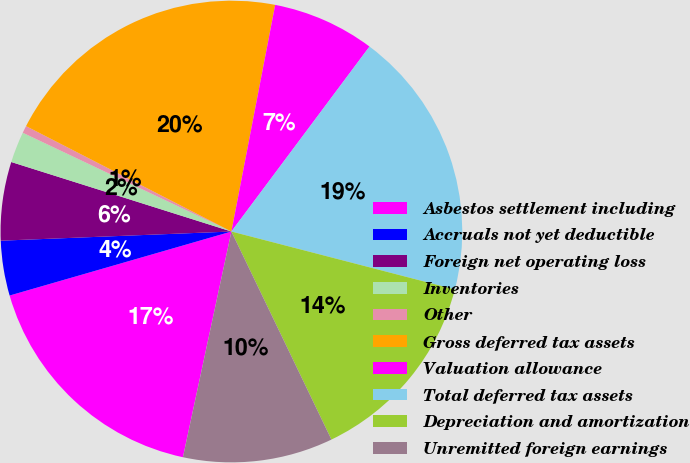Convert chart. <chart><loc_0><loc_0><loc_500><loc_500><pie_chart><fcel>Asbestos settlement including<fcel>Accruals not yet deductible<fcel>Foreign net operating loss<fcel>Inventories<fcel>Other<fcel>Gross deferred tax assets<fcel>Valuation allowance<fcel>Total deferred tax assets<fcel>Depreciation and amortization<fcel>Unremitted foreign earnings<nl><fcel>17.16%<fcel>3.84%<fcel>5.5%<fcel>2.17%<fcel>0.51%<fcel>20.49%<fcel>7.17%<fcel>18.83%<fcel>13.83%<fcel>10.5%<nl></chart> 